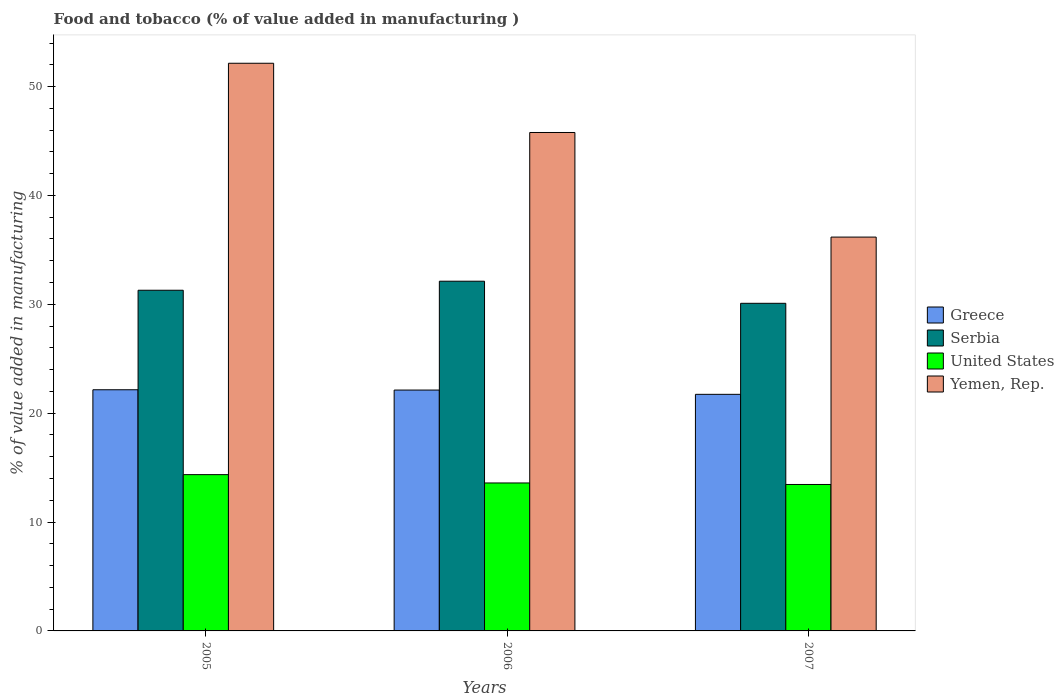How many groups of bars are there?
Make the answer very short. 3. How many bars are there on the 3rd tick from the right?
Provide a short and direct response. 4. What is the label of the 1st group of bars from the left?
Your answer should be very brief. 2005. What is the value added in manufacturing food and tobacco in Serbia in 2005?
Provide a short and direct response. 31.29. Across all years, what is the maximum value added in manufacturing food and tobacco in United States?
Provide a succinct answer. 14.35. Across all years, what is the minimum value added in manufacturing food and tobacco in Yemen, Rep.?
Provide a succinct answer. 36.17. In which year was the value added in manufacturing food and tobacco in Greece maximum?
Offer a terse response. 2005. What is the total value added in manufacturing food and tobacco in United States in the graph?
Keep it short and to the point. 41.4. What is the difference between the value added in manufacturing food and tobacco in United States in 2006 and that in 2007?
Offer a very short reply. 0.14. What is the difference between the value added in manufacturing food and tobacco in United States in 2007 and the value added in manufacturing food and tobacco in Yemen, Rep. in 2005?
Your response must be concise. -38.69. What is the average value added in manufacturing food and tobacco in Greece per year?
Give a very brief answer. 22. In the year 2005, what is the difference between the value added in manufacturing food and tobacco in Greece and value added in manufacturing food and tobacco in United States?
Offer a very short reply. 7.8. What is the ratio of the value added in manufacturing food and tobacco in Yemen, Rep. in 2005 to that in 2006?
Ensure brevity in your answer.  1.14. Is the difference between the value added in manufacturing food and tobacco in Greece in 2006 and 2007 greater than the difference between the value added in manufacturing food and tobacco in United States in 2006 and 2007?
Your answer should be very brief. Yes. What is the difference between the highest and the second highest value added in manufacturing food and tobacco in Greece?
Ensure brevity in your answer.  0.03. What is the difference between the highest and the lowest value added in manufacturing food and tobacco in Yemen, Rep.?
Your answer should be very brief. 15.97. In how many years, is the value added in manufacturing food and tobacco in Greece greater than the average value added in manufacturing food and tobacco in Greece taken over all years?
Your response must be concise. 2. Is the sum of the value added in manufacturing food and tobacco in Yemen, Rep. in 2006 and 2007 greater than the maximum value added in manufacturing food and tobacco in Serbia across all years?
Give a very brief answer. Yes. What does the 1st bar from the left in 2006 represents?
Provide a succinct answer. Greece. What does the 3rd bar from the right in 2005 represents?
Your answer should be compact. Serbia. How many bars are there?
Provide a succinct answer. 12. What is the difference between two consecutive major ticks on the Y-axis?
Make the answer very short. 10. Are the values on the major ticks of Y-axis written in scientific E-notation?
Make the answer very short. No. Does the graph contain any zero values?
Give a very brief answer. No. Does the graph contain grids?
Make the answer very short. No. How are the legend labels stacked?
Offer a terse response. Vertical. What is the title of the graph?
Offer a very short reply. Food and tobacco (% of value added in manufacturing ). What is the label or title of the Y-axis?
Offer a very short reply. % of value added in manufacturing. What is the % of value added in manufacturing in Greece in 2005?
Make the answer very short. 22.15. What is the % of value added in manufacturing in Serbia in 2005?
Your answer should be compact. 31.29. What is the % of value added in manufacturing in United States in 2005?
Make the answer very short. 14.35. What is the % of value added in manufacturing of Yemen, Rep. in 2005?
Your answer should be compact. 52.14. What is the % of value added in manufacturing of Greece in 2006?
Provide a succinct answer. 22.12. What is the % of value added in manufacturing in Serbia in 2006?
Your response must be concise. 32.12. What is the % of value added in manufacturing of United States in 2006?
Provide a succinct answer. 13.59. What is the % of value added in manufacturing in Yemen, Rep. in 2006?
Offer a very short reply. 45.78. What is the % of value added in manufacturing in Greece in 2007?
Your answer should be compact. 21.73. What is the % of value added in manufacturing of Serbia in 2007?
Your answer should be very brief. 30.09. What is the % of value added in manufacturing of United States in 2007?
Your answer should be compact. 13.45. What is the % of value added in manufacturing in Yemen, Rep. in 2007?
Your response must be concise. 36.17. Across all years, what is the maximum % of value added in manufacturing in Greece?
Provide a succinct answer. 22.15. Across all years, what is the maximum % of value added in manufacturing of Serbia?
Offer a terse response. 32.12. Across all years, what is the maximum % of value added in manufacturing in United States?
Your response must be concise. 14.35. Across all years, what is the maximum % of value added in manufacturing of Yemen, Rep.?
Keep it short and to the point. 52.14. Across all years, what is the minimum % of value added in manufacturing in Greece?
Keep it short and to the point. 21.73. Across all years, what is the minimum % of value added in manufacturing of Serbia?
Give a very brief answer. 30.09. Across all years, what is the minimum % of value added in manufacturing in United States?
Your answer should be compact. 13.45. Across all years, what is the minimum % of value added in manufacturing in Yemen, Rep.?
Keep it short and to the point. 36.17. What is the total % of value added in manufacturing of Greece in the graph?
Your answer should be very brief. 66.01. What is the total % of value added in manufacturing in Serbia in the graph?
Give a very brief answer. 93.51. What is the total % of value added in manufacturing in United States in the graph?
Your answer should be compact. 41.4. What is the total % of value added in manufacturing of Yemen, Rep. in the graph?
Your response must be concise. 134.1. What is the difference between the % of value added in manufacturing of Greece in 2005 and that in 2006?
Your response must be concise. 0.03. What is the difference between the % of value added in manufacturing of Serbia in 2005 and that in 2006?
Provide a short and direct response. -0.83. What is the difference between the % of value added in manufacturing of United States in 2005 and that in 2006?
Make the answer very short. 0.76. What is the difference between the % of value added in manufacturing in Yemen, Rep. in 2005 and that in 2006?
Offer a very short reply. 6.36. What is the difference between the % of value added in manufacturing in Greece in 2005 and that in 2007?
Ensure brevity in your answer.  0.42. What is the difference between the % of value added in manufacturing of Serbia in 2005 and that in 2007?
Your answer should be compact. 1.2. What is the difference between the % of value added in manufacturing of United States in 2005 and that in 2007?
Provide a succinct answer. 0.9. What is the difference between the % of value added in manufacturing in Yemen, Rep. in 2005 and that in 2007?
Make the answer very short. 15.97. What is the difference between the % of value added in manufacturing in Greece in 2006 and that in 2007?
Keep it short and to the point. 0.39. What is the difference between the % of value added in manufacturing in Serbia in 2006 and that in 2007?
Offer a terse response. 2.03. What is the difference between the % of value added in manufacturing of United States in 2006 and that in 2007?
Offer a terse response. 0.14. What is the difference between the % of value added in manufacturing of Yemen, Rep. in 2006 and that in 2007?
Provide a short and direct response. 9.61. What is the difference between the % of value added in manufacturing in Greece in 2005 and the % of value added in manufacturing in Serbia in 2006?
Provide a short and direct response. -9.97. What is the difference between the % of value added in manufacturing of Greece in 2005 and the % of value added in manufacturing of United States in 2006?
Offer a terse response. 8.56. What is the difference between the % of value added in manufacturing in Greece in 2005 and the % of value added in manufacturing in Yemen, Rep. in 2006?
Make the answer very short. -23.63. What is the difference between the % of value added in manufacturing of Serbia in 2005 and the % of value added in manufacturing of United States in 2006?
Offer a terse response. 17.7. What is the difference between the % of value added in manufacturing of Serbia in 2005 and the % of value added in manufacturing of Yemen, Rep. in 2006?
Keep it short and to the point. -14.49. What is the difference between the % of value added in manufacturing of United States in 2005 and the % of value added in manufacturing of Yemen, Rep. in 2006?
Provide a short and direct response. -31.43. What is the difference between the % of value added in manufacturing in Greece in 2005 and the % of value added in manufacturing in Serbia in 2007?
Give a very brief answer. -7.94. What is the difference between the % of value added in manufacturing in Greece in 2005 and the % of value added in manufacturing in United States in 2007?
Give a very brief answer. 8.7. What is the difference between the % of value added in manufacturing in Greece in 2005 and the % of value added in manufacturing in Yemen, Rep. in 2007?
Your response must be concise. -14.02. What is the difference between the % of value added in manufacturing in Serbia in 2005 and the % of value added in manufacturing in United States in 2007?
Keep it short and to the point. 17.84. What is the difference between the % of value added in manufacturing of Serbia in 2005 and the % of value added in manufacturing of Yemen, Rep. in 2007?
Provide a succinct answer. -4.88. What is the difference between the % of value added in manufacturing of United States in 2005 and the % of value added in manufacturing of Yemen, Rep. in 2007?
Make the answer very short. -21.82. What is the difference between the % of value added in manufacturing of Greece in 2006 and the % of value added in manufacturing of Serbia in 2007?
Give a very brief answer. -7.97. What is the difference between the % of value added in manufacturing in Greece in 2006 and the % of value added in manufacturing in United States in 2007?
Your answer should be compact. 8.67. What is the difference between the % of value added in manufacturing in Greece in 2006 and the % of value added in manufacturing in Yemen, Rep. in 2007?
Ensure brevity in your answer.  -14.05. What is the difference between the % of value added in manufacturing in Serbia in 2006 and the % of value added in manufacturing in United States in 2007?
Your response must be concise. 18.67. What is the difference between the % of value added in manufacturing of Serbia in 2006 and the % of value added in manufacturing of Yemen, Rep. in 2007?
Your response must be concise. -4.05. What is the difference between the % of value added in manufacturing of United States in 2006 and the % of value added in manufacturing of Yemen, Rep. in 2007?
Provide a short and direct response. -22.58. What is the average % of value added in manufacturing in Greece per year?
Your answer should be very brief. 22. What is the average % of value added in manufacturing in Serbia per year?
Ensure brevity in your answer.  31.17. What is the average % of value added in manufacturing in United States per year?
Make the answer very short. 13.8. What is the average % of value added in manufacturing of Yemen, Rep. per year?
Provide a short and direct response. 44.7. In the year 2005, what is the difference between the % of value added in manufacturing of Greece and % of value added in manufacturing of Serbia?
Provide a short and direct response. -9.14. In the year 2005, what is the difference between the % of value added in manufacturing in Greece and % of value added in manufacturing in United States?
Make the answer very short. 7.8. In the year 2005, what is the difference between the % of value added in manufacturing of Greece and % of value added in manufacturing of Yemen, Rep.?
Offer a terse response. -29.99. In the year 2005, what is the difference between the % of value added in manufacturing of Serbia and % of value added in manufacturing of United States?
Your answer should be very brief. 16.94. In the year 2005, what is the difference between the % of value added in manufacturing of Serbia and % of value added in manufacturing of Yemen, Rep.?
Provide a short and direct response. -20.85. In the year 2005, what is the difference between the % of value added in manufacturing in United States and % of value added in manufacturing in Yemen, Rep.?
Offer a very short reply. -37.79. In the year 2006, what is the difference between the % of value added in manufacturing of Greece and % of value added in manufacturing of Serbia?
Give a very brief answer. -10. In the year 2006, what is the difference between the % of value added in manufacturing of Greece and % of value added in manufacturing of United States?
Provide a short and direct response. 8.53. In the year 2006, what is the difference between the % of value added in manufacturing in Greece and % of value added in manufacturing in Yemen, Rep.?
Ensure brevity in your answer.  -23.66. In the year 2006, what is the difference between the % of value added in manufacturing in Serbia and % of value added in manufacturing in United States?
Your answer should be very brief. 18.53. In the year 2006, what is the difference between the % of value added in manufacturing of Serbia and % of value added in manufacturing of Yemen, Rep.?
Your answer should be compact. -13.66. In the year 2006, what is the difference between the % of value added in manufacturing in United States and % of value added in manufacturing in Yemen, Rep.?
Your answer should be compact. -32.19. In the year 2007, what is the difference between the % of value added in manufacturing of Greece and % of value added in manufacturing of Serbia?
Provide a succinct answer. -8.36. In the year 2007, what is the difference between the % of value added in manufacturing of Greece and % of value added in manufacturing of United States?
Ensure brevity in your answer.  8.28. In the year 2007, what is the difference between the % of value added in manufacturing in Greece and % of value added in manufacturing in Yemen, Rep.?
Offer a very short reply. -14.44. In the year 2007, what is the difference between the % of value added in manufacturing in Serbia and % of value added in manufacturing in United States?
Provide a succinct answer. 16.64. In the year 2007, what is the difference between the % of value added in manufacturing in Serbia and % of value added in manufacturing in Yemen, Rep.?
Provide a succinct answer. -6.08. In the year 2007, what is the difference between the % of value added in manufacturing in United States and % of value added in manufacturing in Yemen, Rep.?
Keep it short and to the point. -22.72. What is the ratio of the % of value added in manufacturing of Greece in 2005 to that in 2006?
Offer a very short reply. 1. What is the ratio of the % of value added in manufacturing of Serbia in 2005 to that in 2006?
Provide a short and direct response. 0.97. What is the ratio of the % of value added in manufacturing in United States in 2005 to that in 2006?
Keep it short and to the point. 1.06. What is the ratio of the % of value added in manufacturing of Yemen, Rep. in 2005 to that in 2006?
Give a very brief answer. 1.14. What is the ratio of the % of value added in manufacturing of Greece in 2005 to that in 2007?
Give a very brief answer. 1.02. What is the ratio of the % of value added in manufacturing of Serbia in 2005 to that in 2007?
Your answer should be very brief. 1.04. What is the ratio of the % of value added in manufacturing in United States in 2005 to that in 2007?
Offer a very short reply. 1.07. What is the ratio of the % of value added in manufacturing of Yemen, Rep. in 2005 to that in 2007?
Provide a succinct answer. 1.44. What is the ratio of the % of value added in manufacturing of Greece in 2006 to that in 2007?
Ensure brevity in your answer.  1.02. What is the ratio of the % of value added in manufacturing in Serbia in 2006 to that in 2007?
Provide a short and direct response. 1.07. What is the ratio of the % of value added in manufacturing of United States in 2006 to that in 2007?
Give a very brief answer. 1.01. What is the ratio of the % of value added in manufacturing of Yemen, Rep. in 2006 to that in 2007?
Give a very brief answer. 1.27. What is the difference between the highest and the second highest % of value added in manufacturing in Greece?
Provide a short and direct response. 0.03. What is the difference between the highest and the second highest % of value added in manufacturing in Serbia?
Offer a terse response. 0.83. What is the difference between the highest and the second highest % of value added in manufacturing in United States?
Provide a short and direct response. 0.76. What is the difference between the highest and the second highest % of value added in manufacturing of Yemen, Rep.?
Your response must be concise. 6.36. What is the difference between the highest and the lowest % of value added in manufacturing of Greece?
Give a very brief answer. 0.42. What is the difference between the highest and the lowest % of value added in manufacturing in Serbia?
Ensure brevity in your answer.  2.03. What is the difference between the highest and the lowest % of value added in manufacturing of United States?
Your answer should be compact. 0.9. What is the difference between the highest and the lowest % of value added in manufacturing of Yemen, Rep.?
Give a very brief answer. 15.97. 